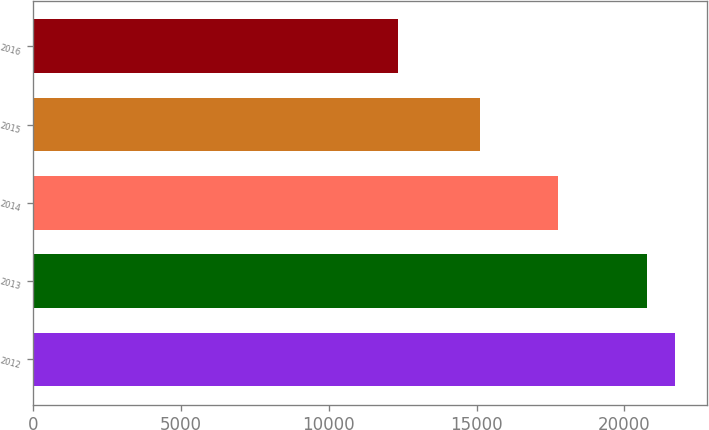Convert chart to OTSL. <chart><loc_0><loc_0><loc_500><loc_500><bar_chart><fcel>2012<fcel>2013<fcel>2014<fcel>2015<fcel>2016<nl><fcel>21713.3<fcel>20780<fcel>17771<fcel>15113<fcel>12342<nl></chart> 